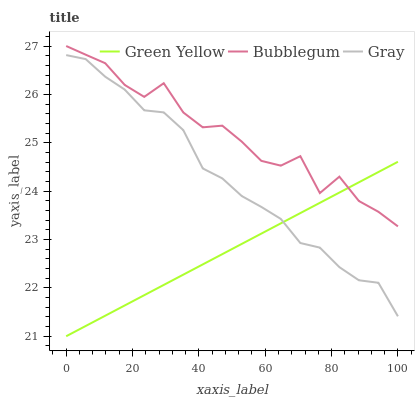Does Bubblegum have the minimum area under the curve?
Answer yes or no. No. Does Green Yellow have the maximum area under the curve?
Answer yes or no. No. Is Bubblegum the smoothest?
Answer yes or no. No. Is Green Yellow the roughest?
Answer yes or no. No. Does Bubblegum have the lowest value?
Answer yes or no. No. Does Green Yellow have the highest value?
Answer yes or no. No. Is Gray less than Bubblegum?
Answer yes or no. Yes. Is Bubblegum greater than Gray?
Answer yes or no. Yes. Does Gray intersect Bubblegum?
Answer yes or no. No. 